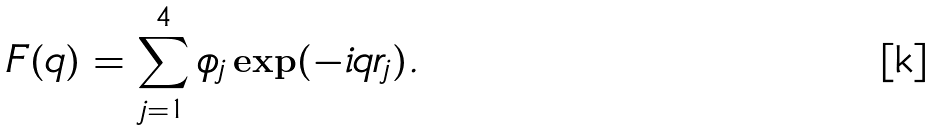<formula> <loc_0><loc_0><loc_500><loc_500>F ( q ) = \sum _ { j = 1 } ^ { 4 } \phi _ { j } \exp ( - i q r _ { j } ) .</formula> 